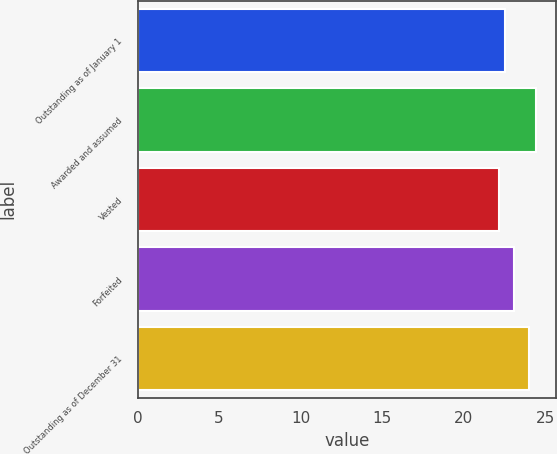Convert chart to OTSL. <chart><loc_0><loc_0><loc_500><loc_500><bar_chart><fcel>Outstanding as of January 1<fcel>Awarded and assumed<fcel>Vested<fcel>Forfeited<fcel>Outstanding as of December 31<nl><fcel>22.5<fcel>24.41<fcel>22.15<fcel>23.09<fcel>24<nl></chart> 